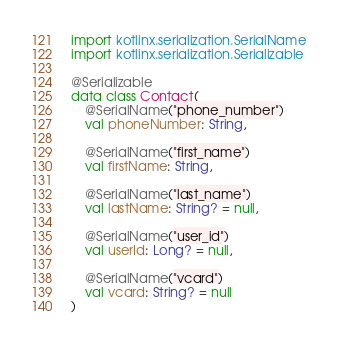Convert code to text. <code><loc_0><loc_0><loc_500><loc_500><_Kotlin_>import kotlinx.serialization.SerialName
import kotlinx.serialization.Serializable

@Serializable
data class Contact(
    @SerialName("phone_number")
    val phoneNumber: String,

    @SerialName("first_name")
    val firstName: String,

    @SerialName("last_name")
    val lastName: String? = null,

    @SerialName("user_id")
    val userId: Long? = null,

    @SerialName("vcard")
    val vcard: String? = null
)</code> 